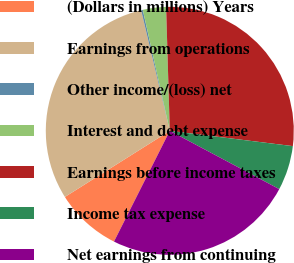Convert chart to OTSL. <chart><loc_0><loc_0><loc_500><loc_500><pie_chart><fcel>(Dollars in millions) Years<fcel>Earnings from operations<fcel>Other income/(loss) net<fcel>Interest and debt expense<fcel>Earnings before income taxes<fcel>Income tax expense<fcel>Net earnings from continuing<nl><fcel>8.62%<fcel>30.24%<fcel>0.22%<fcel>3.02%<fcel>27.44%<fcel>5.82%<fcel>24.64%<nl></chart> 